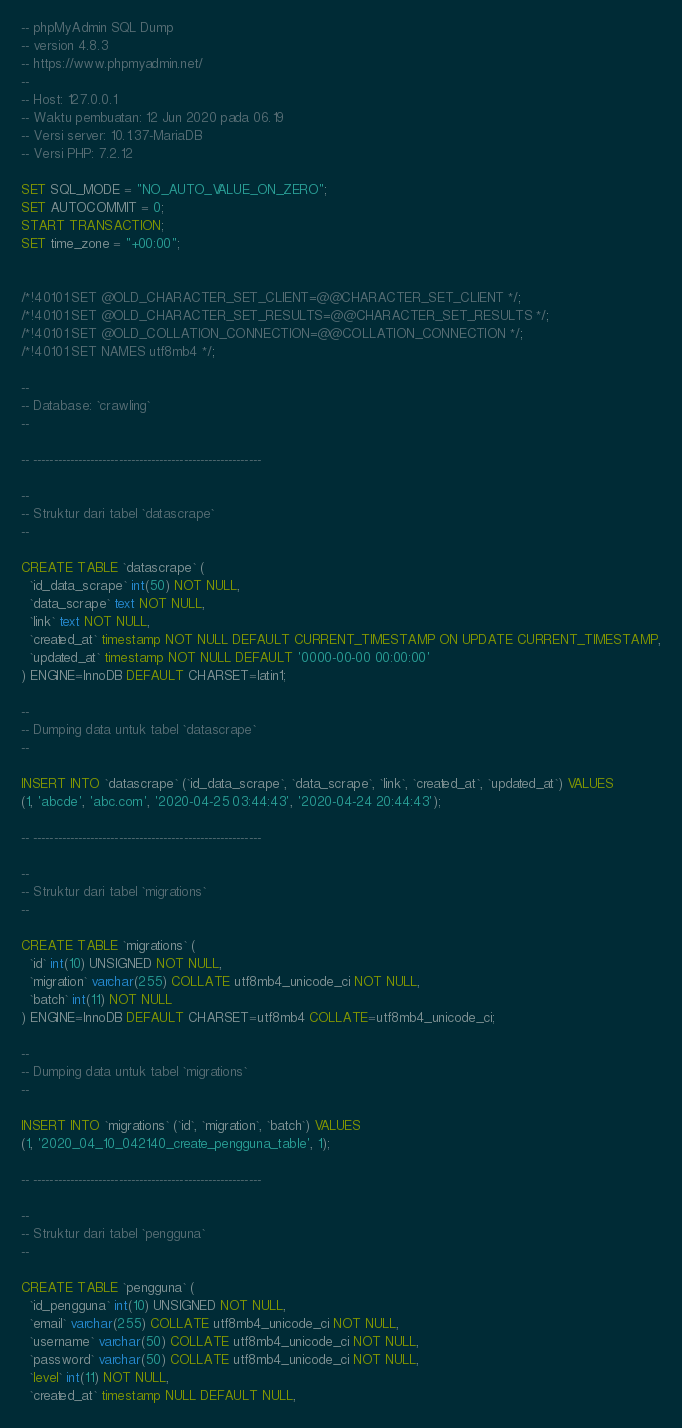<code> <loc_0><loc_0><loc_500><loc_500><_SQL_>-- phpMyAdmin SQL Dump
-- version 4.8.3
-- https://www.phpmyadmin.net/
--
-- Host: 127.0.0.1
-- Waktu pembuatan: 12 Jun 2020 pada 06.19
-- Versi server: 10.1.37-MariaDB
-- Versi PHP: 7.2.12

SET SQL_MODE = "NO_AUTO_VALUE_ON_ZERO";
SET AUTOCOMMIT = 0;
START TRANSACTION;
SET time_zone = "+00:00";


/*!40101 SET @OLD_CHARACTER_SET_CLIENT=@@CHARACTER_SET_CLIENT */;
/*!40101 SET @OLD_CHARACTER_SET_RESULTS=@@CHARACTER_SET_RESULTS */;
/*!40101 SET @OLD_COLLATION_CONNECTION=@@COLLATION_CONNECTION */;
/*!40101 SET NAMES utf8mb4 */;

--
-- Database: `crawling`
--

-- --------------------------------------------------------

--
-- Struktur dari tabel `datascrape`
--

CREATE TABLE `datascrape` (
  `id_data_scrape` int(50) NOT NULL,
  `data_scrape` text NOT NULL,
  `link` text NOT NULL,
  `created_at` timestamp NOT NULL DEFAULT CURRENT_TIMESTAMP ON UPDATE CURRENT_TIMESTAMP,
  `updated_at` timestamp NOT NULL DEFAULT '0000-00-00 00:00:00'
) ENGINE=InnoDB DEFAULT CHARSET=latin1;

--
-- Dumping data untuk tabel `datascrape`
--

INSERT INTO `datascrape` (`id_data_scrape`, `data_scrape`, `link`, `created_at`, `updated_at`) VALUES
(1, 'abcde', 'abc.com', '2020-04-25 03:44:43', '2020-04-24 20:44:43');

-- --------------------------------------------------------

--
-- Struktur dari tabel `migrations`
--

CREATE TABLE `migrations` (
  `id` int(10) UNSIGNED NOT NULL,
  `migration` varchar(255) COLLATE utf8mb4_unicode_ci NOT NULL,
  `batch` int(11) NOT NULL
) ENGINE=InnoDB DEFAULT CHARSET=utf8mb4 COLLATE=utf8mb4_unicode_ci;

--
-- Dumping data untuk tabel `migrations`
--

INSERT INTO `migrations` (`id`, `migration`, `batch`) VALUES
(1, '2020_04_10_042140_create_pengguna_table', 1);

-- --------------------------------------------------------

--
-- Struktur dari tabel `pengguna`
--

CREATE TABLE `pengguna` (
  `id_pengguna` int(10) UNSIGNED NOT NULL,
  `email` varchar(255) COLLATE utf8mb4_unicode_ci NOT NULL,
  `username` varchar(50) COLLATE utf8mb4_unicode_ci NOT NULL,
  `password` varchar(50) COLLATE utf8mb4_unicode_ci NOT NULL,
  `level` int(11) NOT NULL,
  `created_at` timestamp NULL DEFAULT NULL,</code> 